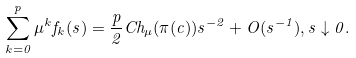Convert formula to latex. <formula><loc_0><loc_0><loc_500><loc_500>\sum _ { k = 0 } ^ { p } \mu ^ { k } f _ { k } ( s ) = \frac { p } { 2 } C h _ { \mu } ( \pi ( c ) ) s ^ { - 2 } + O ( s ^ { - 1 } ) , s \downarrow 0 .</formula> 